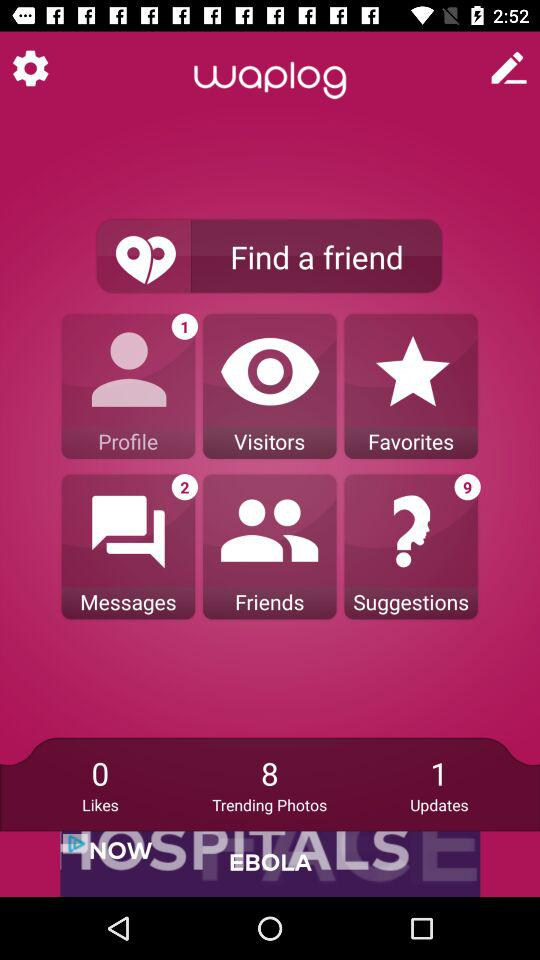How many likes are there? There are 0 likes. 